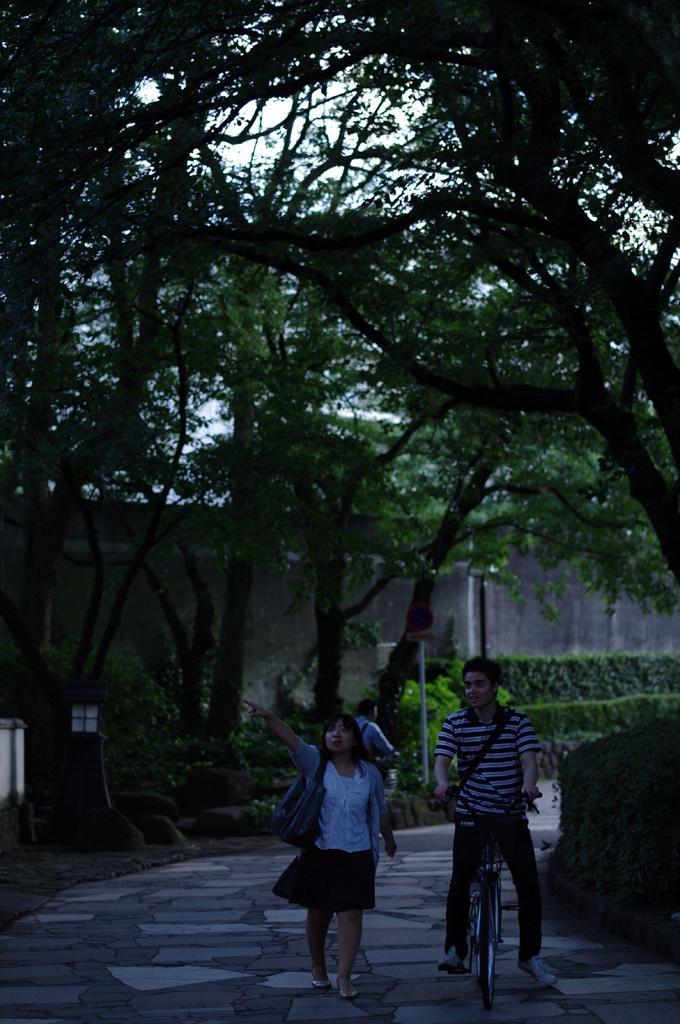Describe this image in one or two sentences. This image is taken in outdoors. At the top of the image there are many trees and a sky and a wall behind the trees. There are few plants in this image. In the left side of the image there is a light. In the middle of the image there is a woman walking on a sidewalk and a man riding on bicycle. In the left side of the image a man is riding on a bicycle back of him there is a sign board. 